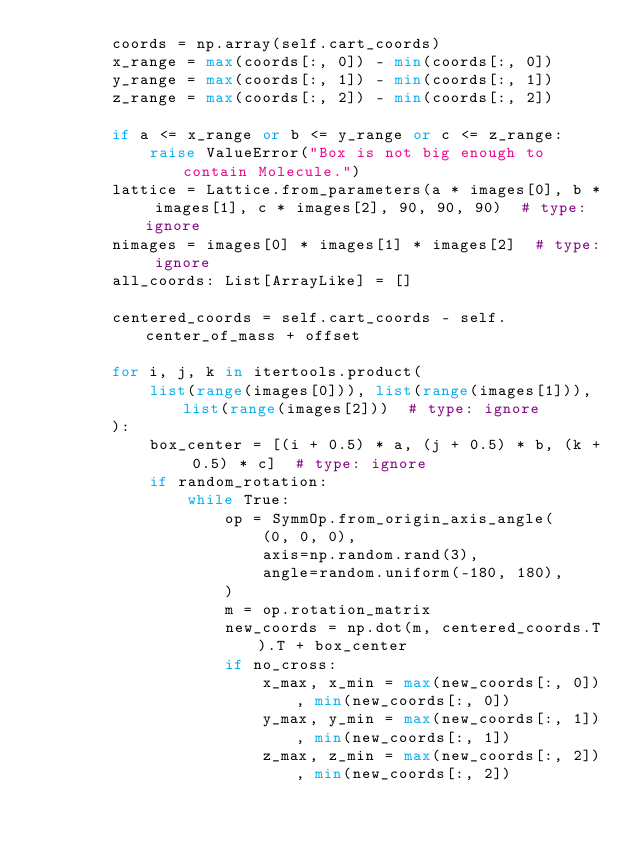Convert code to text. <code><loc_0><loc_0><loc_500><loc_500><_Python_>        coords = np.array(self.cart_coords)
        x_range = max(coords[:, 0]) - min(coords[:, 0])
        y_range = max(coords[:, 1]) - min(coords[:, 1])
        z_range = max(coords[:, 2]) - min(coords[:, 2])

        if a <= x_range or b <= y_range or c <= z_range:
            raise ValueError("Box is not big enough to contain Molecule.")
        lattice = Lattice.from_parameters(a * images[0], b * images[1], c * images[2], 90, 90, 90)  # type: ignore
        nimages = images[0] * images[1] * images[2]  # type: ignore
        all_coords: List[ArrayLike] = []

        centered_coords = self.cart_coords - self.center_of_mass + offset

        for i, j, k in itertools.product(
            list(range(images[0])), list(range(images[1])), list(range(images[2]))  # type: ignore
        ):
            box_center = [(i + 0.5) * a, (j + 0.5) * b, (k + 0.5) * c]  # type: ignore
            if random_rotation:
                while True:
                    op = SymmOp.from_origin_axis_angle(
                        (0, 0, 0),
                        axis=np.random.rand(3),
                        angle=random.uniform(-180, 180),
                    )
                    m = op.rotation_matrix
                    new_coords = np.dot(m, centered_coords.T).T + box_center
                    if no_cross:
                        x_max, x_min = max(new_coords[:, 0]), min(new_coords[:, 0])
                        y_max, y_min = max(new_coords[:, 1]), min(new_coords[:, 1])
                        z_max, z_min = max(new_coords[:, 2]), min(new_coords[:, 2])</code> 